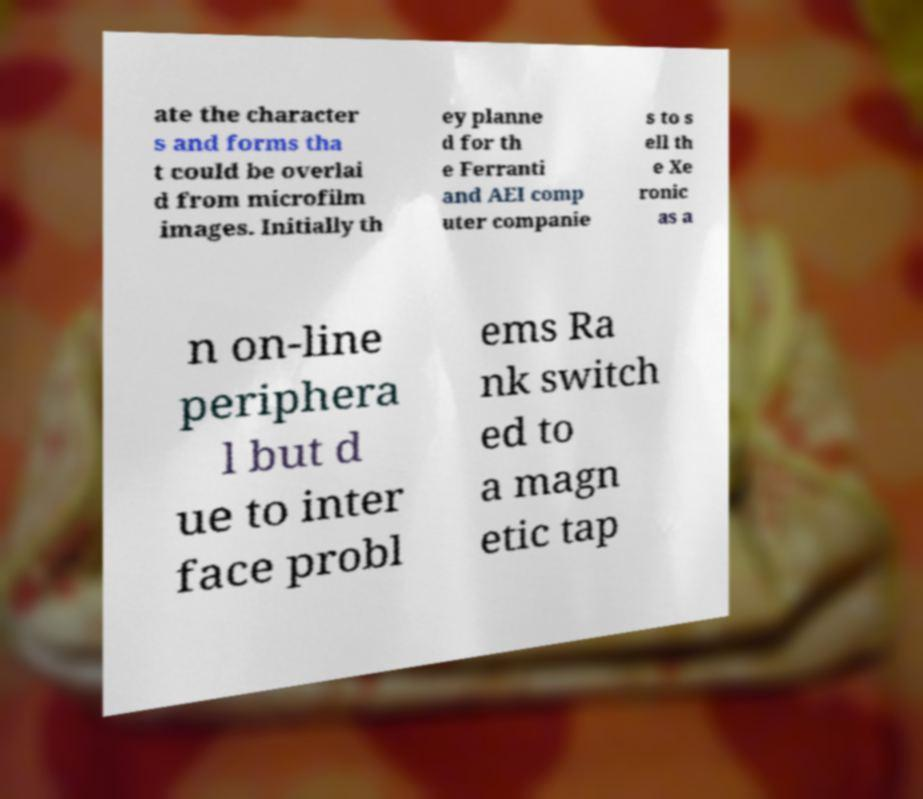Can you accurately transcribe the text from the provided image for me? ate the character s and forms tha t could be overlai d from microfilm images. Initially th ey planne d for th e Ferranti and AEI comp uter companie s to s ell th e Xe ronic as a n on-line periphera l but d ue to inter face probl ems Ra nk switch ed to a magn etic tap 